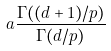<formula> <loc_0><loc_0><loc_500><loc_500>a \frac { \Gamma ( ( d + 1 ) / p ) } { \Gamma ( d / p ) }</formula> 